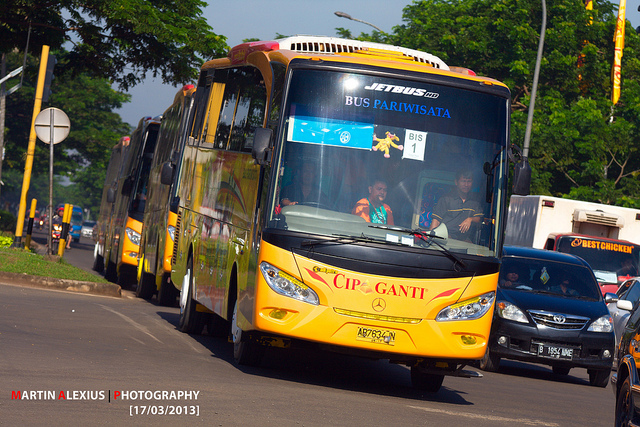Imagine a magical scene involving this bus. Imagine this bus as a magical, transforming vehicle known as the 'Wonder Coach.' Every night, after the tourism hours, it becomes enchanted, turning into a spectacular flying bus. Its wheels become shimmering orbs, the windows glow with ethereal light, and it rises into the air, taking its passengers on mystical journeys across dreamlike landscapes filled with floating islands, magical creatures, and shimmering spires. The bus's interior transforms into a luxurious lounge with plush seating and a ceiling that opens up to the starry sky, allowing passengers to gaze upon the cosmos as they glide through the night. 